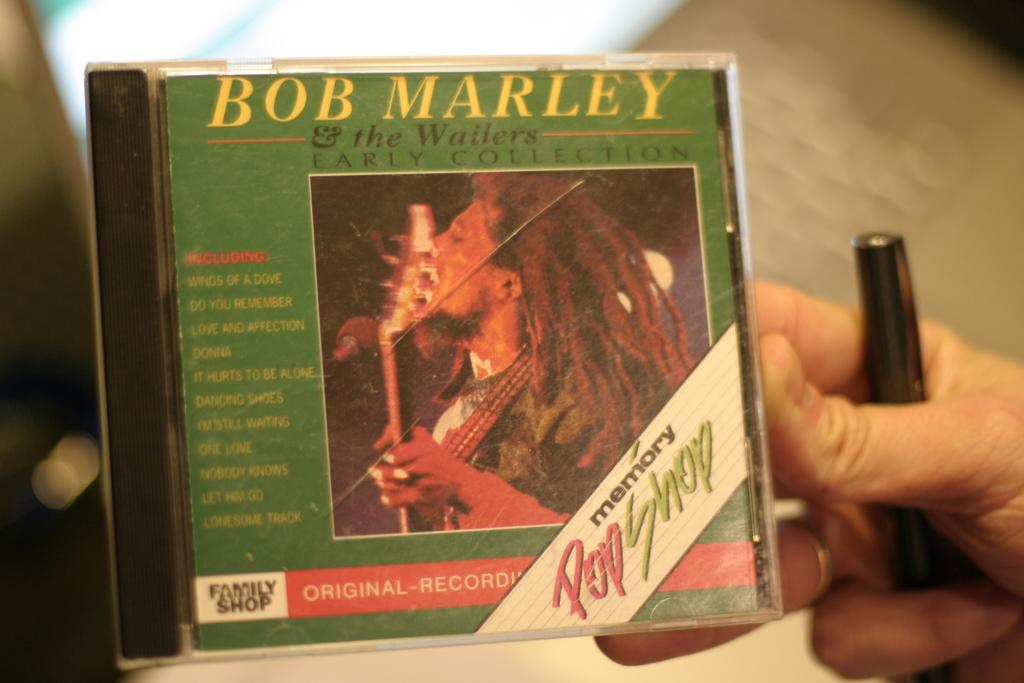What is the person in the image holding in their hand? The person is holding a pen and a cassette. What can be found on the cassette? There is text on the cassette. What is the second person in the image holding? The second person is holding a guitar. Can you describe the background of the image? The background of the image is blurred. What type of honey is being used to tune the guitar in the image? There is no honey present in the image, and the guitar is not being tuned. 